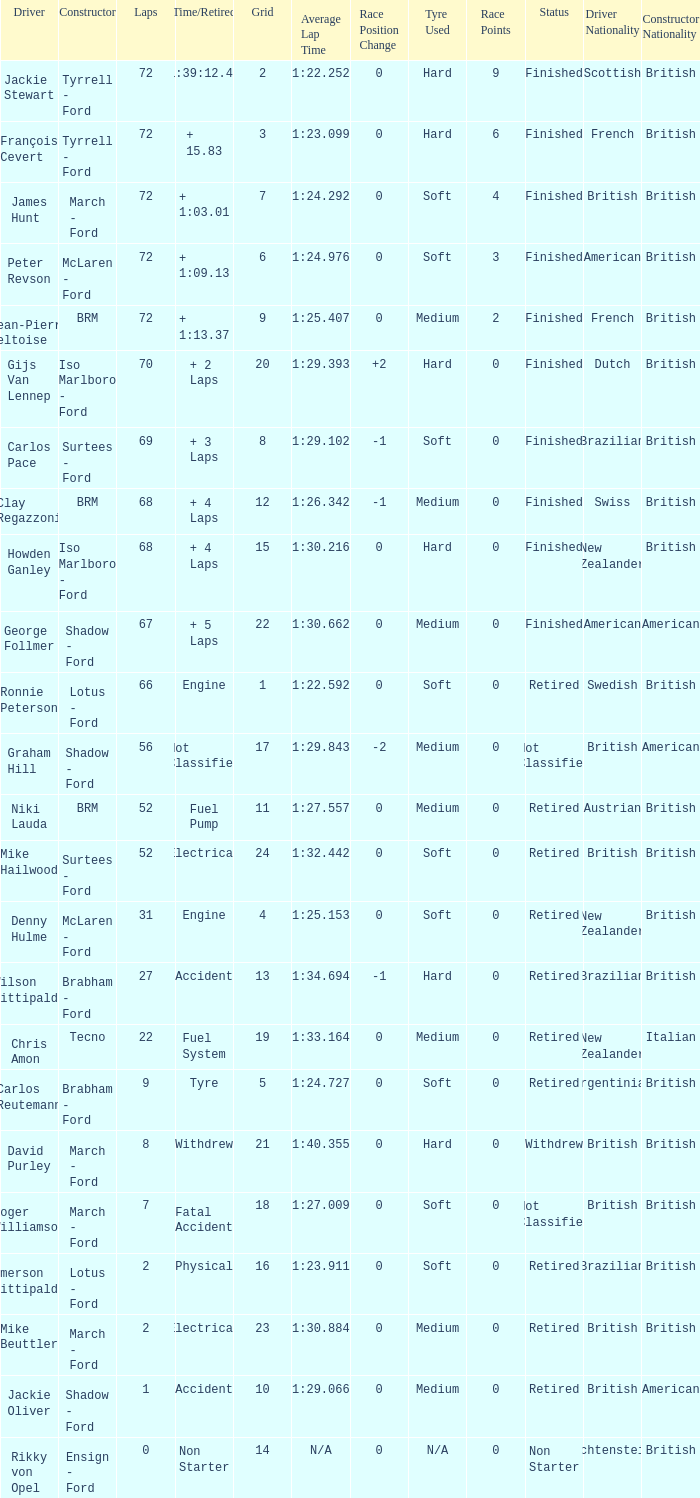What is the top grid that roger williamson lapped less than 7? None. 